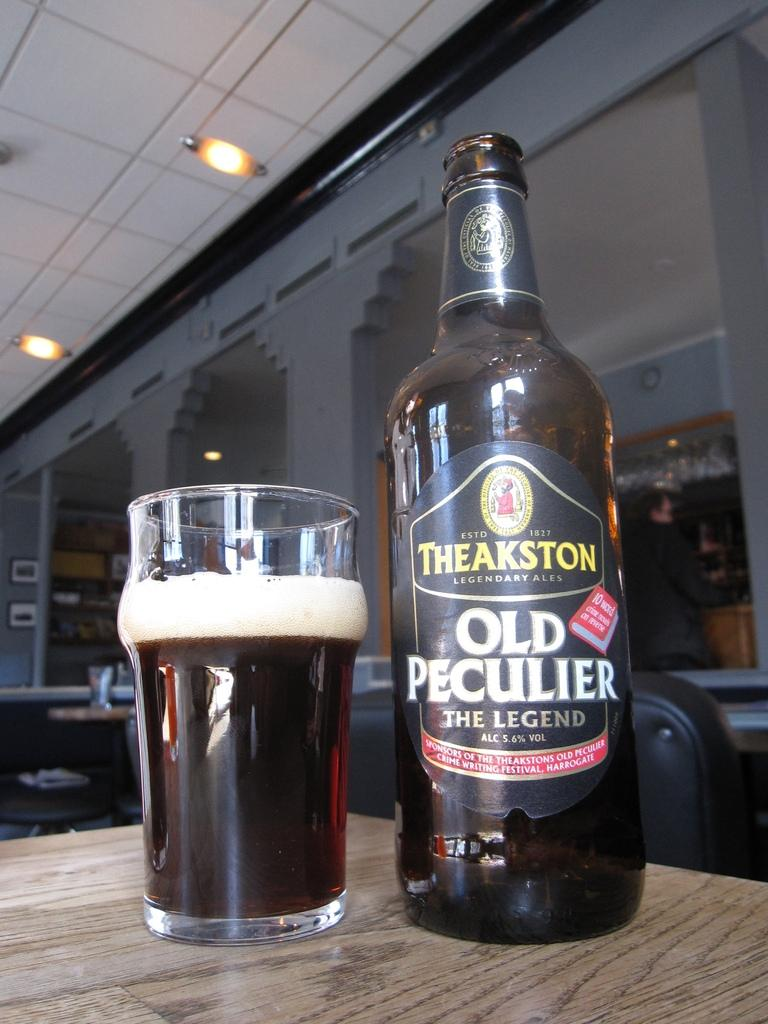<image>
Write a terse but informative summary of the picture. Old Peculiar is the flavor of the beer being poured. 